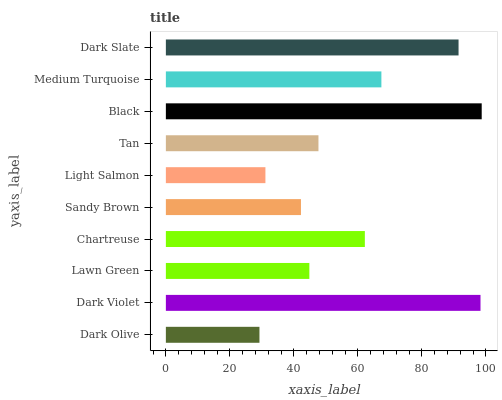Is Dark Olive the minimum?
Answer yes or no. Yes. Is Black the maximum?
Answer yes or no. Yes. Is Dark Violet the minimum?
Answer yes or no. No. Is Dark Violet the maximum?
Answer yes or no. No. Is Dark Violet greater than Dark Olive?
Answer yes or no. Yes. Is Dark Olive less than Dark Violet?
Answer yes or no. Yes. Is Dark Olive greater than Dark Violet?
Answer yes or no. No. Is Dark Violet less than Dark Olive?
Answer yes or no. No. Is Chartreuse the high median?
Answer yes or no. Yes. Is Tan the low median?
Answer yes or no. Yes. Is Medium Turquoise the high median?
Answer yes or no. No. Is Lawn Green the low median?
Answer yes or no. No. 